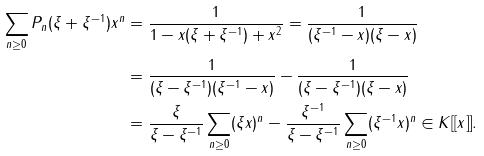Convert formula to latex. <formula><loc_0><loc_0><loc_500><loc_500>\sum _ { n \geq 0 } P _ { n } ( \xi + \xi ^ { - 1 } ) x ^ { n } & = \frac { 1 } { 1 - x ( \xi + \xi ^ { - 1 } ) + x ^ { 2 } } = \frac { 1 } { ( \xi ^ { - 1 } - x ) ( \xi - x ) } \\ & = \frac { 1 } { ( \xi - \xi ^ { - 1 } ) ( \xi ^ { - 1 } - x ) } - \frac { 1 } { ( \xi - \xi ^ { - 1 } ) ( \xi - x ) } \\ & = \frac { \xi } { \xi - \xi ^ { - 1 } } \sum _ { n \geq 0 } ( \xi x ) ^ { n } - \frac { \xi ^ { - 1 } } { \xi - \xi ^ { - 1 } } \sum _ { n \geq 0 } ( \xi ^ { - 1 } x ) ^ { n } \in K [ [ x ] ] .</formula> 